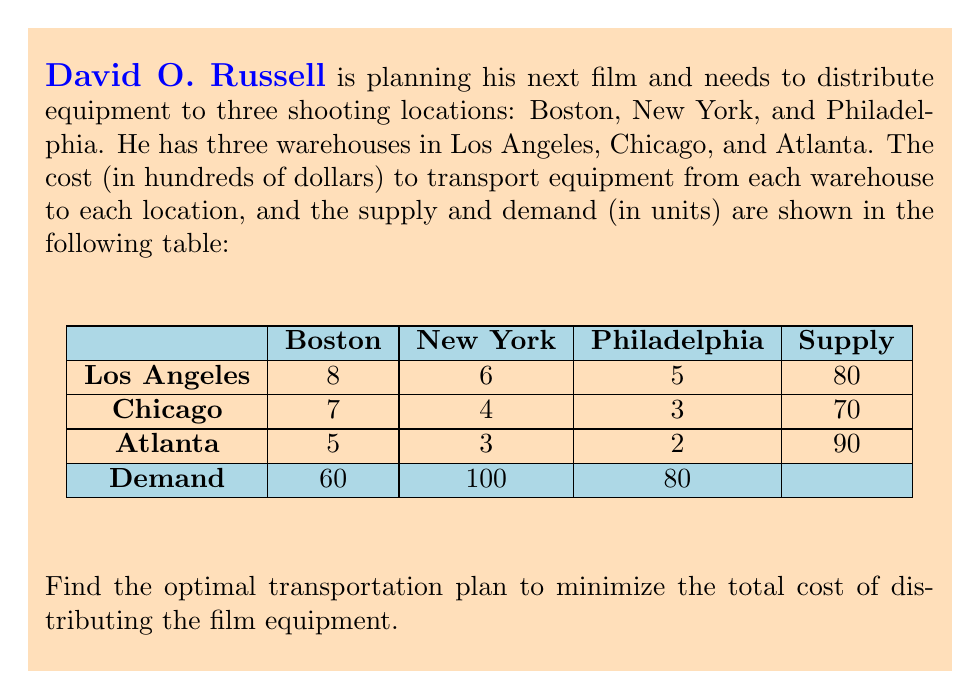Can you answer this question? To solve this transportation problem, we'll use the Northwest Corner Method to find an initial feasible solution, then optimize it using the Stepping Stone Method.

Step 1: Northwest Corner Method

Start from the top-left corner and allocate as much as possible:
- Boston-Los Angeles: 60 units
- New York-Los Angeles: 20 units
- New York-Chicago: 70 units
- New York-Atlanta: 10 units
- Philadelphia-Atlanta: 80 units

Initial solution:
$$
\begin{array}{c|ccc|c}
 & \text{Boston} & \text{New York} & \text{Philadelphia} & \text{Supply} \\
\hline
\text{Los Angeles} & 60 & 20 & 0 & 80 \\
\text{Chicago} & 0 & 70 & 0 & 70 \\
\text{Atlanta} & 0 & 10 & 80 & 90 \\
\hline
\text{Demand} & 60 & 100 & 80 & 
\end{array}
$$

Step 2: Calculate initial cost
$$(60 \times 8) + (20 \times 6) + (70 \times 4) + (10 \times 3) + (80 \times 2) = 1010$$

Step 3: Check for optimality using the Stepping Stone Method

Calculate the opportunity cost for each unused route:
- Boston-Chicago: $u_1 + v_1 - c_{11} = 7 - 7 = 0$
- Boston-Atlanta: $u_1 + v_1 - c_{21} = 5 - 5 = 0$
- Philadelphia-Los Angeles: $u_3 + v_3 - c_{13} = 5 - 5 = 0$
- Philadelphia-Chicago: $u_3 + v_3 - c_{23} = 3 - 3 = 0$

Since all opportunity costs are non-negative, the initial solution is optimal.

Step 4: Verify total supply equals total demand
$80 + 70 + 90 = 240 = 60 + 100 + 80$

Therefore, the initial solution is also the optimal solution.
Answer: Optimal distribution: Los Angeles to Boston (60) and New York (20); Chicago to New York (70); Atlanta to New York (10) and Philadelphia (80). Total cost: $101,000. 